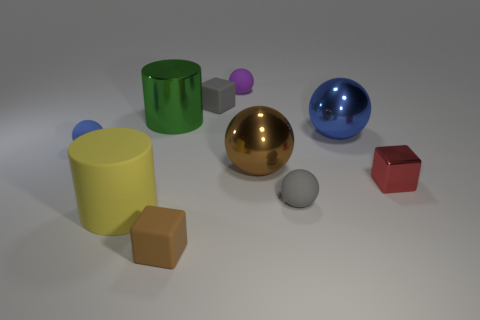Subtract all blue metal spheres. How many spheres are left? 4 Subtract 1 spheres. How many spheres are left? 4 Subtract all brown balls. How many balls are left? 4 Subtract all yellow spheres. Subtract all cyan blocks. How many spheres are left? 5 Subtract all cylinders. How many objects are left? 8 Add 5 small metallic objects. How many small metallic objects exist? 6 Subtract 0 purple cylinders. How many objects are left? 10 Subtract all small yellow objects. Subtract all big yellow rubber objects. How many objects are left? 9 Add 3 big green cylinders. How many big green cylinders are left? 4 